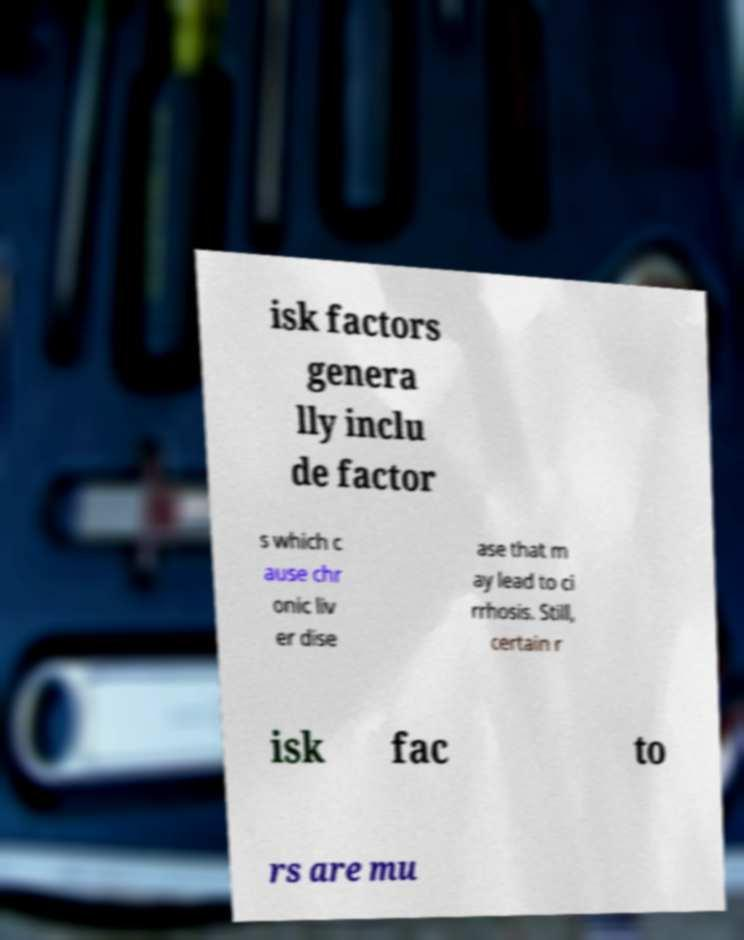There's text embedded in this image that I need extracted. Can you transcribe it verbatim? isk factors genera lly inclu de factor s which c ause chr onic liv er dise ase that m ay lead to ci rrhosis. Still, certain r isk fac to rs are mu 